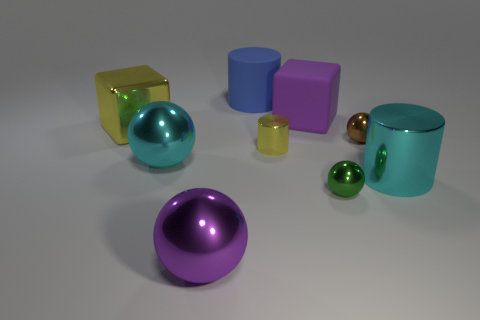Add 1 brown metallic objects. How many objects exist? 10 Subtract all cubes. How many objects are left? 7 Subtract all brown things. Subtract all large red metal objects. How many objects are left? 8 Add 2 metal cylinders. How many metal cylinders are left? 4 Add 8 tiny brown blocks. How many tiny brown blocks exist? 8 Subtract 0 gray cylinders. How many objects are left? 9 